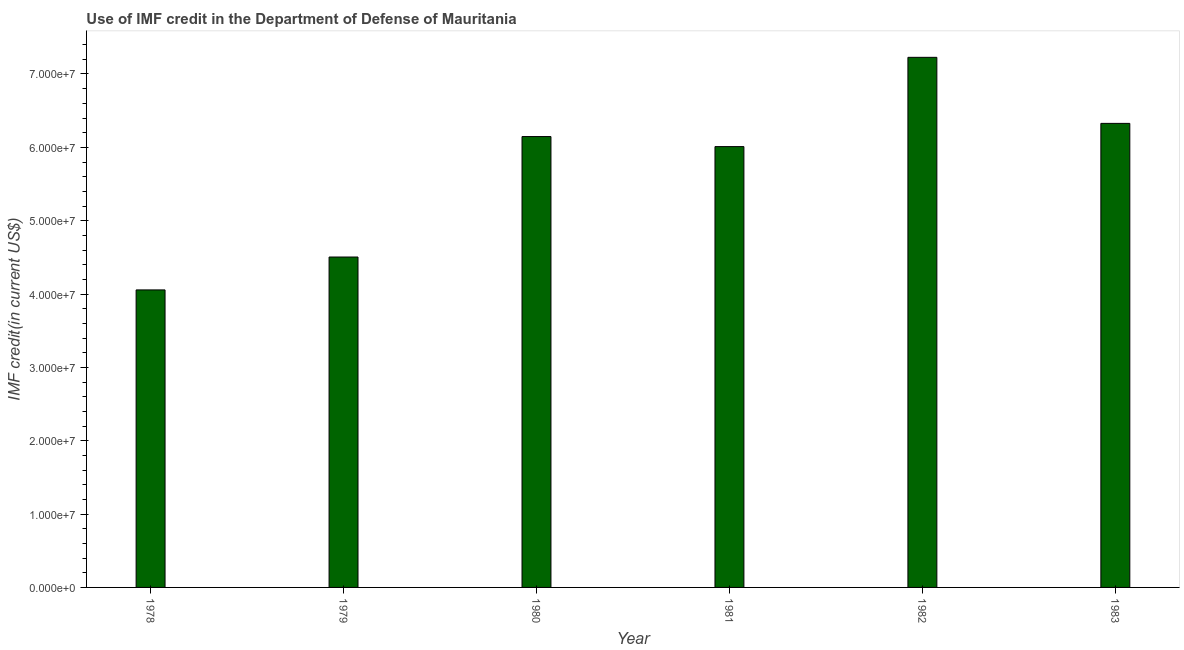What is the title of the graph?
Your answer should be very brief. Use of IMF credit in the Department of Defense of Mauritania. What is the label or title of the X-axis?
Provide a succinct answer. Year. What is the label or title of the Y-axis?
Your response must be concise. IMF credit(in current US$). What is the use of imf credit in dod in 1979?
Your response must be concise. 4.50e+07. Across all years, what is the maximum use of imf credit in dod?
Your answer should be very brief. 7.23e+07. Across all years, what is the minimum use of imf credit in dod?
Your answer should be compact. 4.06e+07. In which year was the use of imf credit in dod maximum?
Offer a terse response. 1982. In which year was the use of imf credit in dod minimum?
Your response must be concise. 1978. What is the sum of the use of imf credit in dod?
Provide a succinct answer. 3.43e+08. What is the difference between the use of imf credit in dod in 1978 and 1983?
Provide a succinct answer. -2.27e+07. What is the average use of imf credit in dod per year?
Your response must be concise. 5.71e+07. What is the median use of imf credit in dod?
Your response must be concise. 6.08e+07. What is the ratio of the use of imf credit in dod in 1981 to that in 1983?
Your answer should be compact. 0.95. Is the difference between the use of imf credit in dod in 1981 and 1982 greater than the difference between any two years?
Provide a short and direct response. No. What is the difference between the highest and the second highest use of imf credit in dod?
Your answer should be compact. 9.01e+06. What is the difference between the highest and the lowest use of imf credit in dod?
Provide a succinct answer. 3.17e+07. Are the values on the major ticks of Y-axis written in scientific E-notation?
Keep it short and to the point. Yes. What is the IMF credit(in current US$) of 1978?
Your response must be concise. 4.06e+07. What is the IMF credit(in current US$) in 1979?
Provide a short and direct response. 4.50e+07. What is the IMF credit(in current US$) in 1980?
Offer a terse response. 6.15e+07. What is the IMF credit(in current US$) in 1981?
Your answer should be compact. 6.01e+07. What is the IMF credit(in current US$) of 1982?
Give a very brief answer. 7.23e+07. What is the IMF credit(in current US$) in 1983?
Provide a succinct answer. 6.33e+07. What is the difference between the IMF credit(in current US$) in 1978 and 1979?
Your answer should be very brief. -4.48e+06. What is the difference between the IMF credit(in current US$) in 1978 and 1980?
Ensure brevity in your answer.  -2.09e+07. What is the difference between the IMF credit(in current US$) in 1978 and 1981?
Provide a succinct answer. -1.95e+07. What is the difference between the IMF credit(in current US$) in 1978 and 1982?
Your answer should be very brief. -3.17e+07. What is the difference between the IMF credit(in current US$) in 1978 and 1983?
Your response must be concise. -2.27e+07. What is the difference between the IMF credit(in current US$) in 1979 and 1980?
Make the answer very short. -1.64e+07. What is the difference between the IMF credit(in current US$) in 1979 and 1981?
Your answer should be very brief. -1.51e+07. What is the difference between the IMF credit(in current US$) in 1979 and 1982?
Your response must be concise. -2.72e+07. What is the difference between the IMF credit(in current US$) in 1979 and 1983?
Give a very brief answer. -1.82e+07. What is the difference between the IMF credit(in current US$) in 1980 and 1981?
Ensure brevity in your answer.  1.37e+06. What is the difference between the IMF credit(in current US$) in 1980 and 1982?
Your response must be concise. -1.08e+07. What is the difference between the IMF credit(in current US$) in 1980 and 1983?
Offer a terse response. -1.80e+06. What is the difference between the IMF credit(in current US$) in 1981 and 1982?
Give a very brief answer. -1.22e+07. What is the difference between the IMF credit(in current US$) in 1981 and 1983?
Your response must be concise. -3.17e+06. What is the difference between the IMF credit(in current US$) in 1982 and 1983?
Provide a succinct answer. 9.01e+06. What is the ratio of the IMF credit(in current US$) in 1978 to that in 1980?
Your answer should be compact. 0.66. What is the ratio of the IMF credit(in current US$) in 1978 to that in 1981?
Your response must be concise. 0.68. What is the ratio of the IMF credit(in current US$) in 1978 to that in 1982?
Offer a very short reply. 0.56. What is the ratio of the IMF credit(in current US$) in 1978 to that in 1983?
Ensure brevity in your answer.  0.64. What is the ratio of the IMF credit(in current US$) in 1979 to that in 1980?
Provide a succinct answer. 0.73. What is the ratio of the IMF credit(in current US$) in 1979 to that in 1981?
Keep it short and to the point. 0.75. What is the ratio of the IMF credit(in current US$) in 1979 to that in 1982?
Ensure brevity in your answer.  0.62. What is the ratio of the IMF credit(in current US$) in 1979 to that in 1983?
Give a very brief answer. 0.71. What is the ratio of the IMF credit(in current US$) in 1980 to that in 1981?
Provide a short and direct response. 1.02. What is the ratio of the IMF credit(in current US$) in 1980 to that in 1982?
Provide a short and direct response. 0.85. What is the ratio of the IMF credit(in current US$) in 1981 to that in 1982?
Your response must be concise. 0.83. What is the ratio of the IMF credit(in current US$) in 1982 to that in 1983?
Offer a terse response. 1.14. 